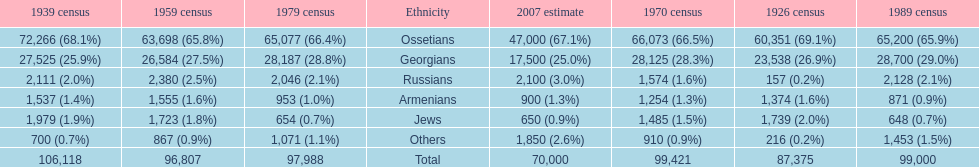What was the first census that saw a russian population of over 2,000? 1939 census. 